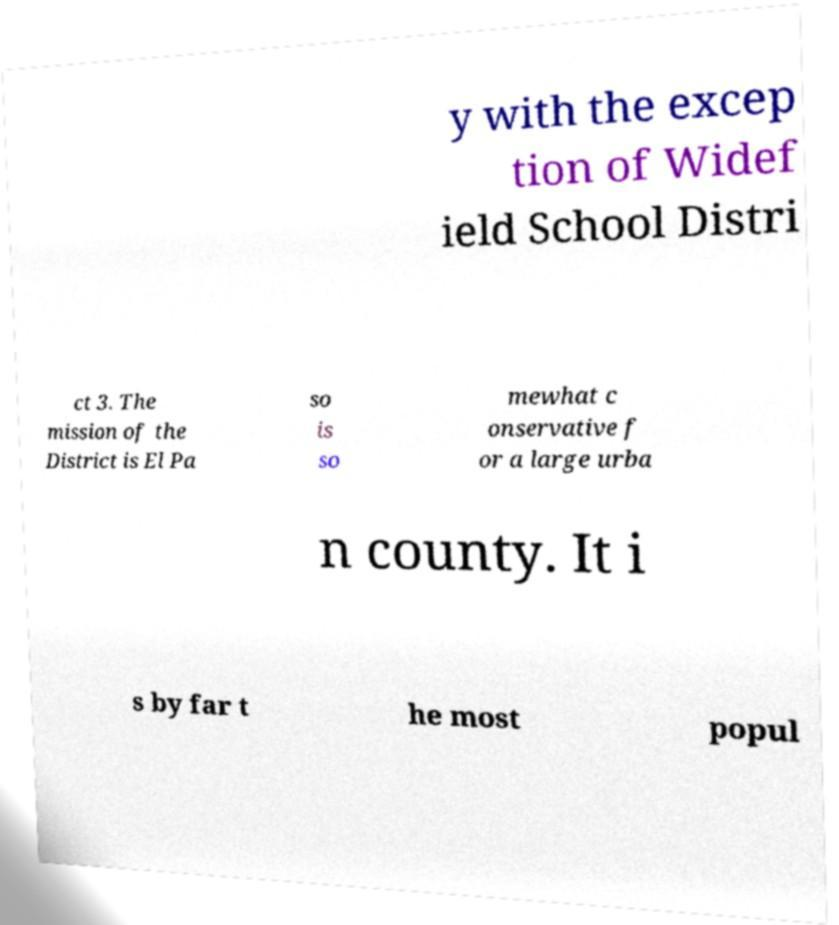For documentation purposes, I need the text within this image transcribed. Could you provide that? y with the excep tion of Widef ield School Distri ct 3. The mission of the District is El Pa so is so mewhat c onservative f or a large urba n county. It i s by far t he most popul 